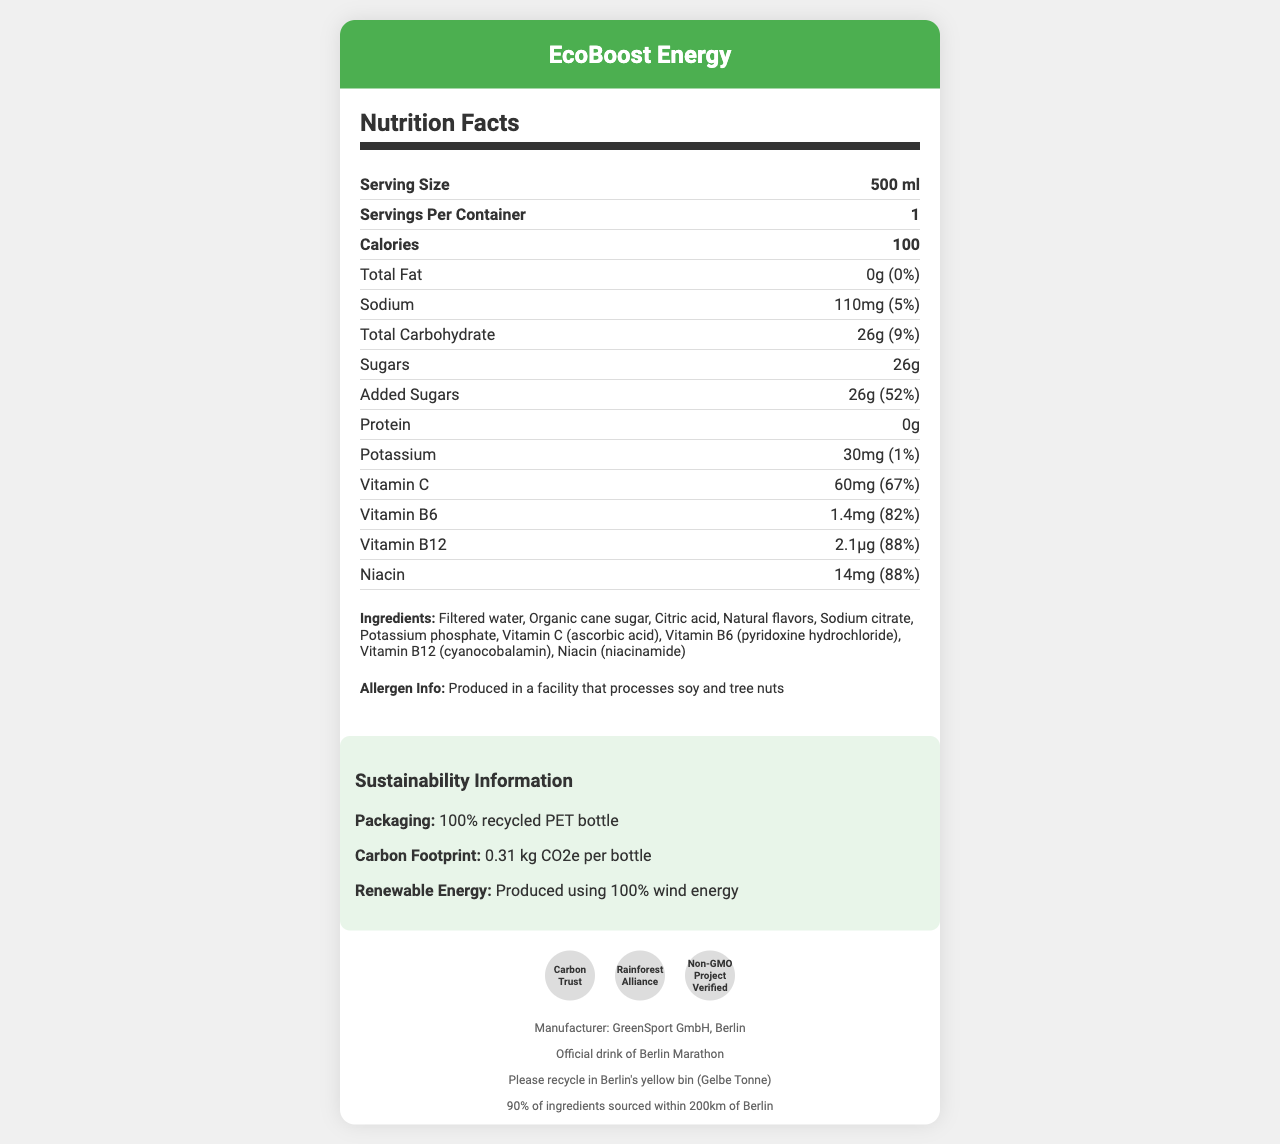what is the serving size of EcoBoost Energy? The serving size is directly stated as "500 ml" in the Nutrition Facts section under "Serving Size."
Answer: 500 ml how many calories are in one serving? The document lists the calorie content as "100" in the bold section of the Nutrition Facts.
Answer: 100 what is the amount of sodium per serving? The amount of sodium is presented as "110 mg" with a daily value percentage of "5%."
Answer: 110 mg what percentage of the daily value of vitamin C does one serving provide? The document specifies the vitamin C content as "60 mg" and states it fulfills "67%" of the daily value.
Answer: 67% what is the carbon footprint per bottle of EcoBoost Energy? Under the sustainability information, the carbon footprint is listed as "0.31 kg CO2e per bottle."
Answer: 0.31 kg CO2e to the nearest percentage, what is the daily value of added sugars provided by one serving of EcoBoost Energy? The added sugars information specifies "26g" contributing to "52%" of the daily value.
Answer: 52% how much protein is there in a serving of EcoBoost Energy? A. 0g B. 1g C. 5g D. 10g The document states there is "0g" of protein per serving.
Answer: A. 0g which of the following certifications does EcoBoost Energy have? A. Organic B. Carbon Trust C. Fair Trade D. Gluten-Free The document lists "Carbon Trust," "Rainforest Alliance," and "Non-GMO Project Verified" as certifications, but not "Organic" or "Fair Trade."
Answer: B. Carbon Trust does the packaging of EcoBoost Energy use recycled materials? Under sustainability information, it is mentioned that the packaging is a "100% recycled PET bottle."
Answer: Yes describe the main idea of the document. The document details various aspects of EcoBoost Energy, concentrating on its nutrients, sustainable packaging, carbon footprint, manufacturing details, and official endorsements.
Answer: The document provides a comprehensive overview of the nutritional facts, ingredients, allergen information, sustainability initiatives, and certifications of EcoBoost Energy, a sports drink produced by GreenSport GmbH in Berlin. It emphasizes the drink's health benefits, sustainable packaging, carbon footprint, and its official association with the Berlin Marathon. what is the manufacturer of EcoBoost Energy? The bottom section of the document specifies that the manufacturer is "GreenSport GmbH, Berlin."
Answer: GreenSport GmbH, Berlin what is the percentage of local ingredients sourced within 200km of Berlin? It is clearly stated in the additional information section that "90% of ingredients are sourced within 200km of Berlin."
Answer: 90% can you determine if EcoBoost Energy is vegan from the document? The document does not specify whether the product is vegan or not. It only provides allergen information, but not specifics on whether it is suitable for vegans.
Answer: Not enough information 